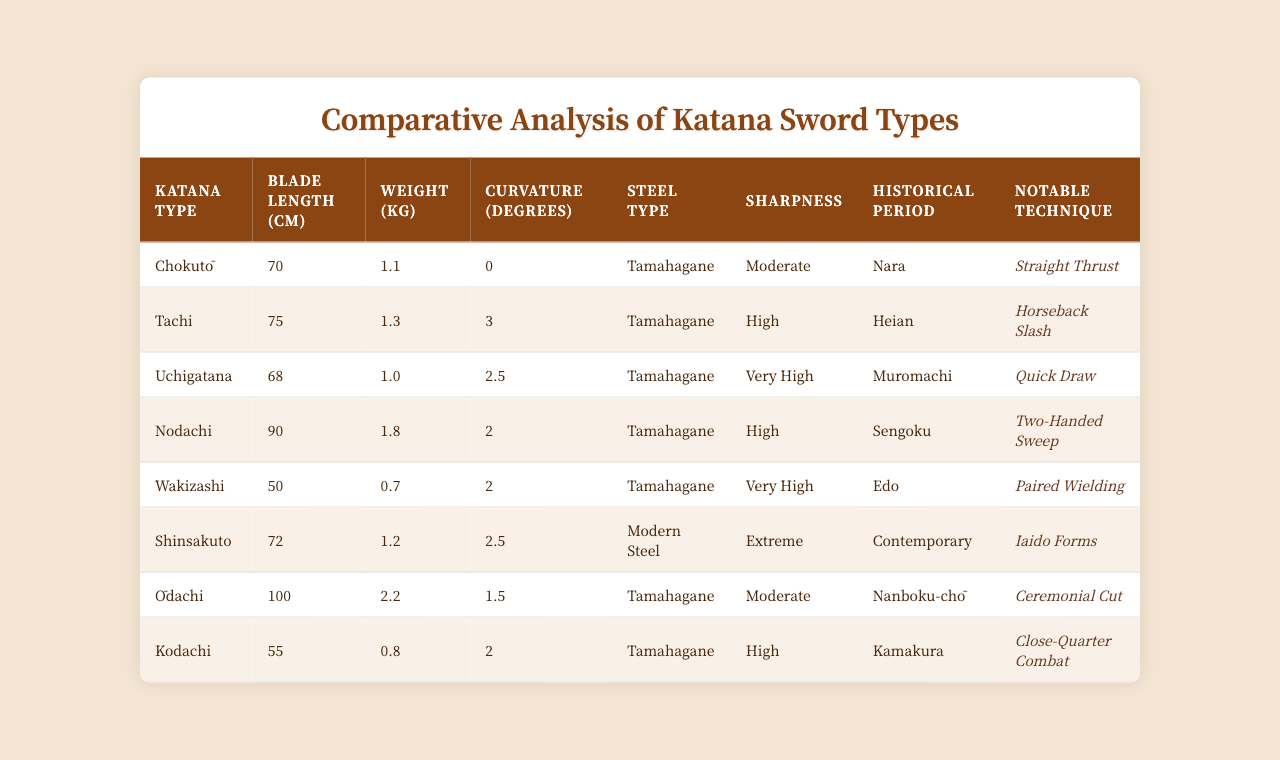What is the blade length of a Wakizashi? The table lists the Wakizashi under "Katana Type" and shows its blade length as 50 cm.
Answer: 50 cm Which katana type has the highest weight? By comparing the "Weight (kg)" column for all katana types, the Ōdachi is the heaviest at 2.2 kg.
Answer: Ōdachi Is the Chokutō more curved than the Tachi? The Chokutō has a curvature of 0 degrees, while the Tachi has a curvature of 3 degrees, making the Tachi more curved.
Answer: No What is the average blade length of all katana types listed? The blade lengths are 70, 75, 68, 90, 50, 72, 100, and 55 cm. Summing these gives 70 + 75 + 68 + 90 + 50 + 72 + 100 + 55 = 600 cm. There are 8 types, so the average is 600/8 = 75 cm.
Answer: 75 cm Which katana type is known for paired wielding? The Wakizashi is specifically noted in the table for the technique of paired wielding.
Answer: Wakizashi Are all katana types made of Tamahagane steel? The table shows that the Shinsakuto is made of Modern Steel, while the rest are made of Tamahagane. Thus, not all katana types are made of Tamahagane.
Answer: No What notable technique is associated with the Uchigatana? The last column in the row for the Uchigatana indicates that its notable technique is "Quick Draw."
Answer: Quick Draw Which katana type has both high sharpness and low weight? By examining the "Weight (kg)" and "Sharpness" columns, the Wakizashi has a weight of 0.7 kg and sharpness rated as very high.
Answer: Wakizashi How many katana types are classified from the Edo period? The Wakizashi is the only katana type listed from the Edo period in the "Historical Period" column.
Answer: 1 What is the difference in curvature between the Nodachi and the Kodachi? The Nodachi has a curvature of 2 degrees, and the Kodachi has a curvature of 2 degrees as well. Therefore, the difference is 2 - 2 = 0 degrees.
Answer: 0 degrees 